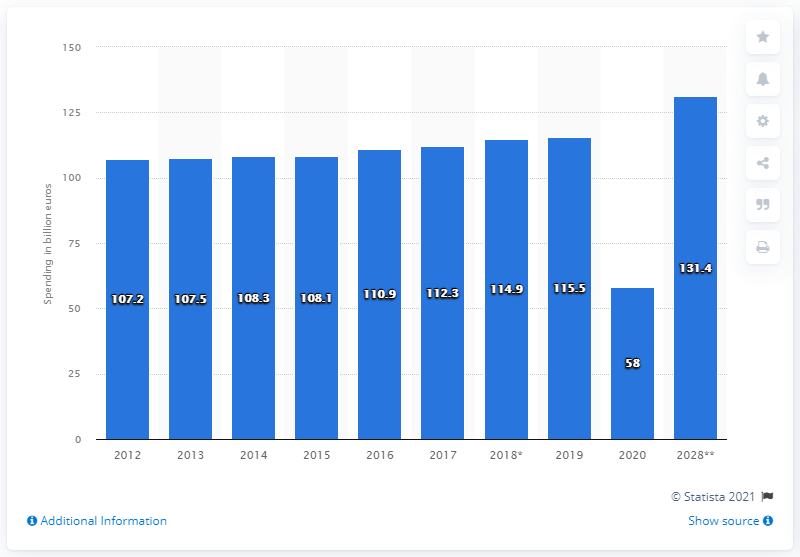Domestic tourism expenditure is expected to reach what in 2028?
 131.4 